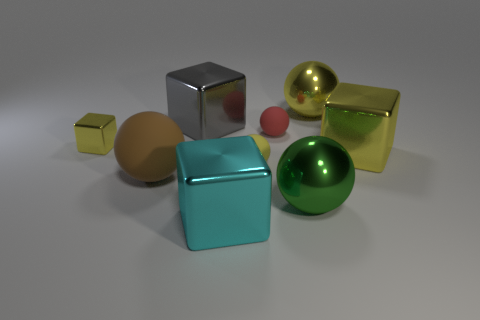How do the different objects in the image relate to each other in terms of color? The objects display a variety of colors that create a visually harmonious palette. The shades range from pastel tones, like the turquoise cube, to rich metallic tints, such as the gold and silver cubes, suggesting a deliberate arrangement to showcase contrast and complementation among colors. 